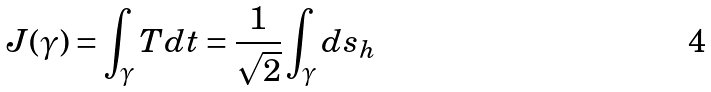<formula> <loc_0><loc_0><loc_500><loc_500>J ( \gamma ) = \int _ { \gamma } T d t = \frac { 1 } { \sqrt { 2 } } \int _ { \gamma } d s _ { h }</formula> 